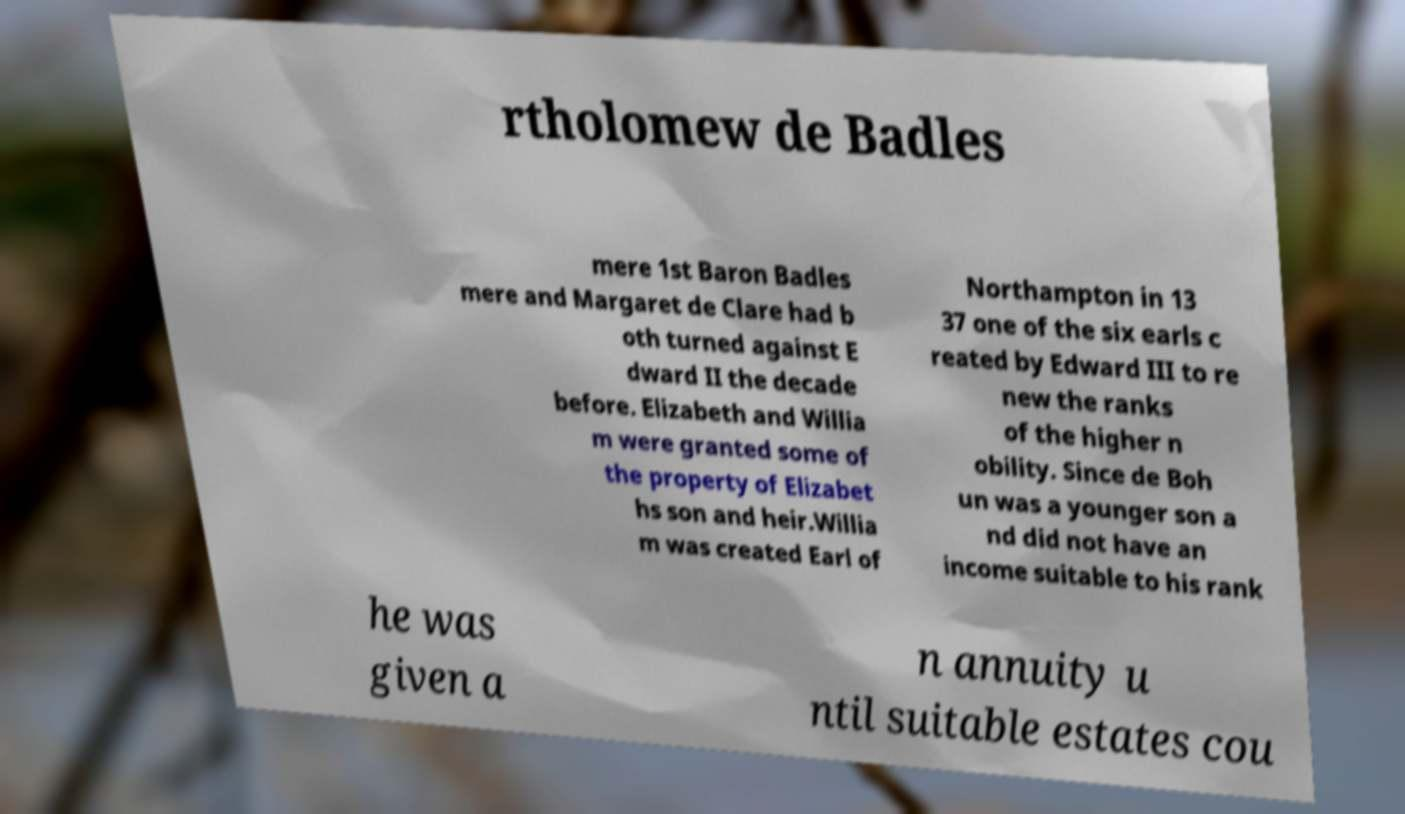Please read and relay the text visible in this image. What does it say? rtholomew de Badles mere 1st Baron Badles mere and Margaret de Clare had b oth turned against E dward II the decade before. Elizabeth and Willia m were granted some of the property of Elizabet hs son and heir.Willia m was created Earl of Northampton in 13 37 one of the six earls c reated by Edward III to re new the ranks of the higher n obility. Since de Boh un was a younger son a nd did not have an income suitable to his rank he was given a n annuity u ntil suitable estates cou 